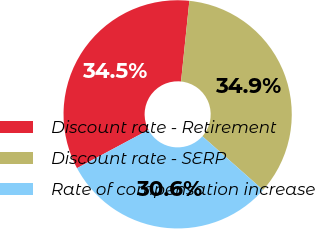<chart> <loc_0><loc_0><loc_500><loc_500><pie_chart><fcel>Discount rate - Retirement<fcel>Discount rate - SERP<fcel>Rate of compensation increase<nl><fcel>34.46%<fcel>34.91%<fcel>30.64%<nl></chart> 